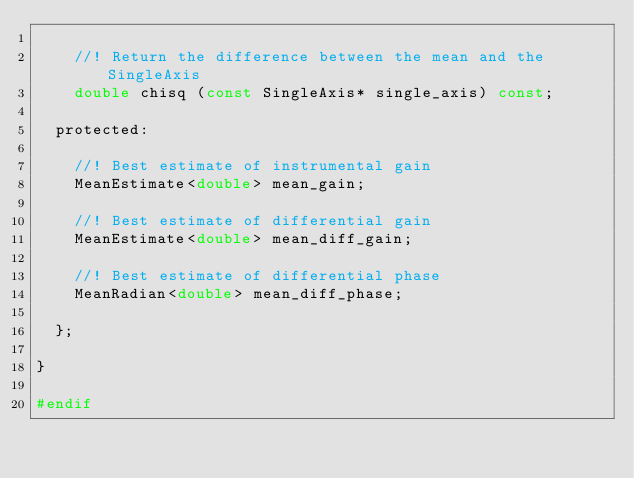Convert code to text. <code><loc_0><loc_0><loc_500><loc_500><_C_>
    //! Return the difference between the mean and the SingleAxis
    double chisq (const SingleAxis* single_axis) const;

  protected:

    //! Best estimate of instrumental gain
    MeanEstimate<double> mean_gain;

    //! Best estimate of differential gain
    MeanEstimate<double> mean_diff_gain;

    //! Best estimate of differential phase
    MeanRadian<double> mean_diff_phase;

  };

}

#endif

</code> 